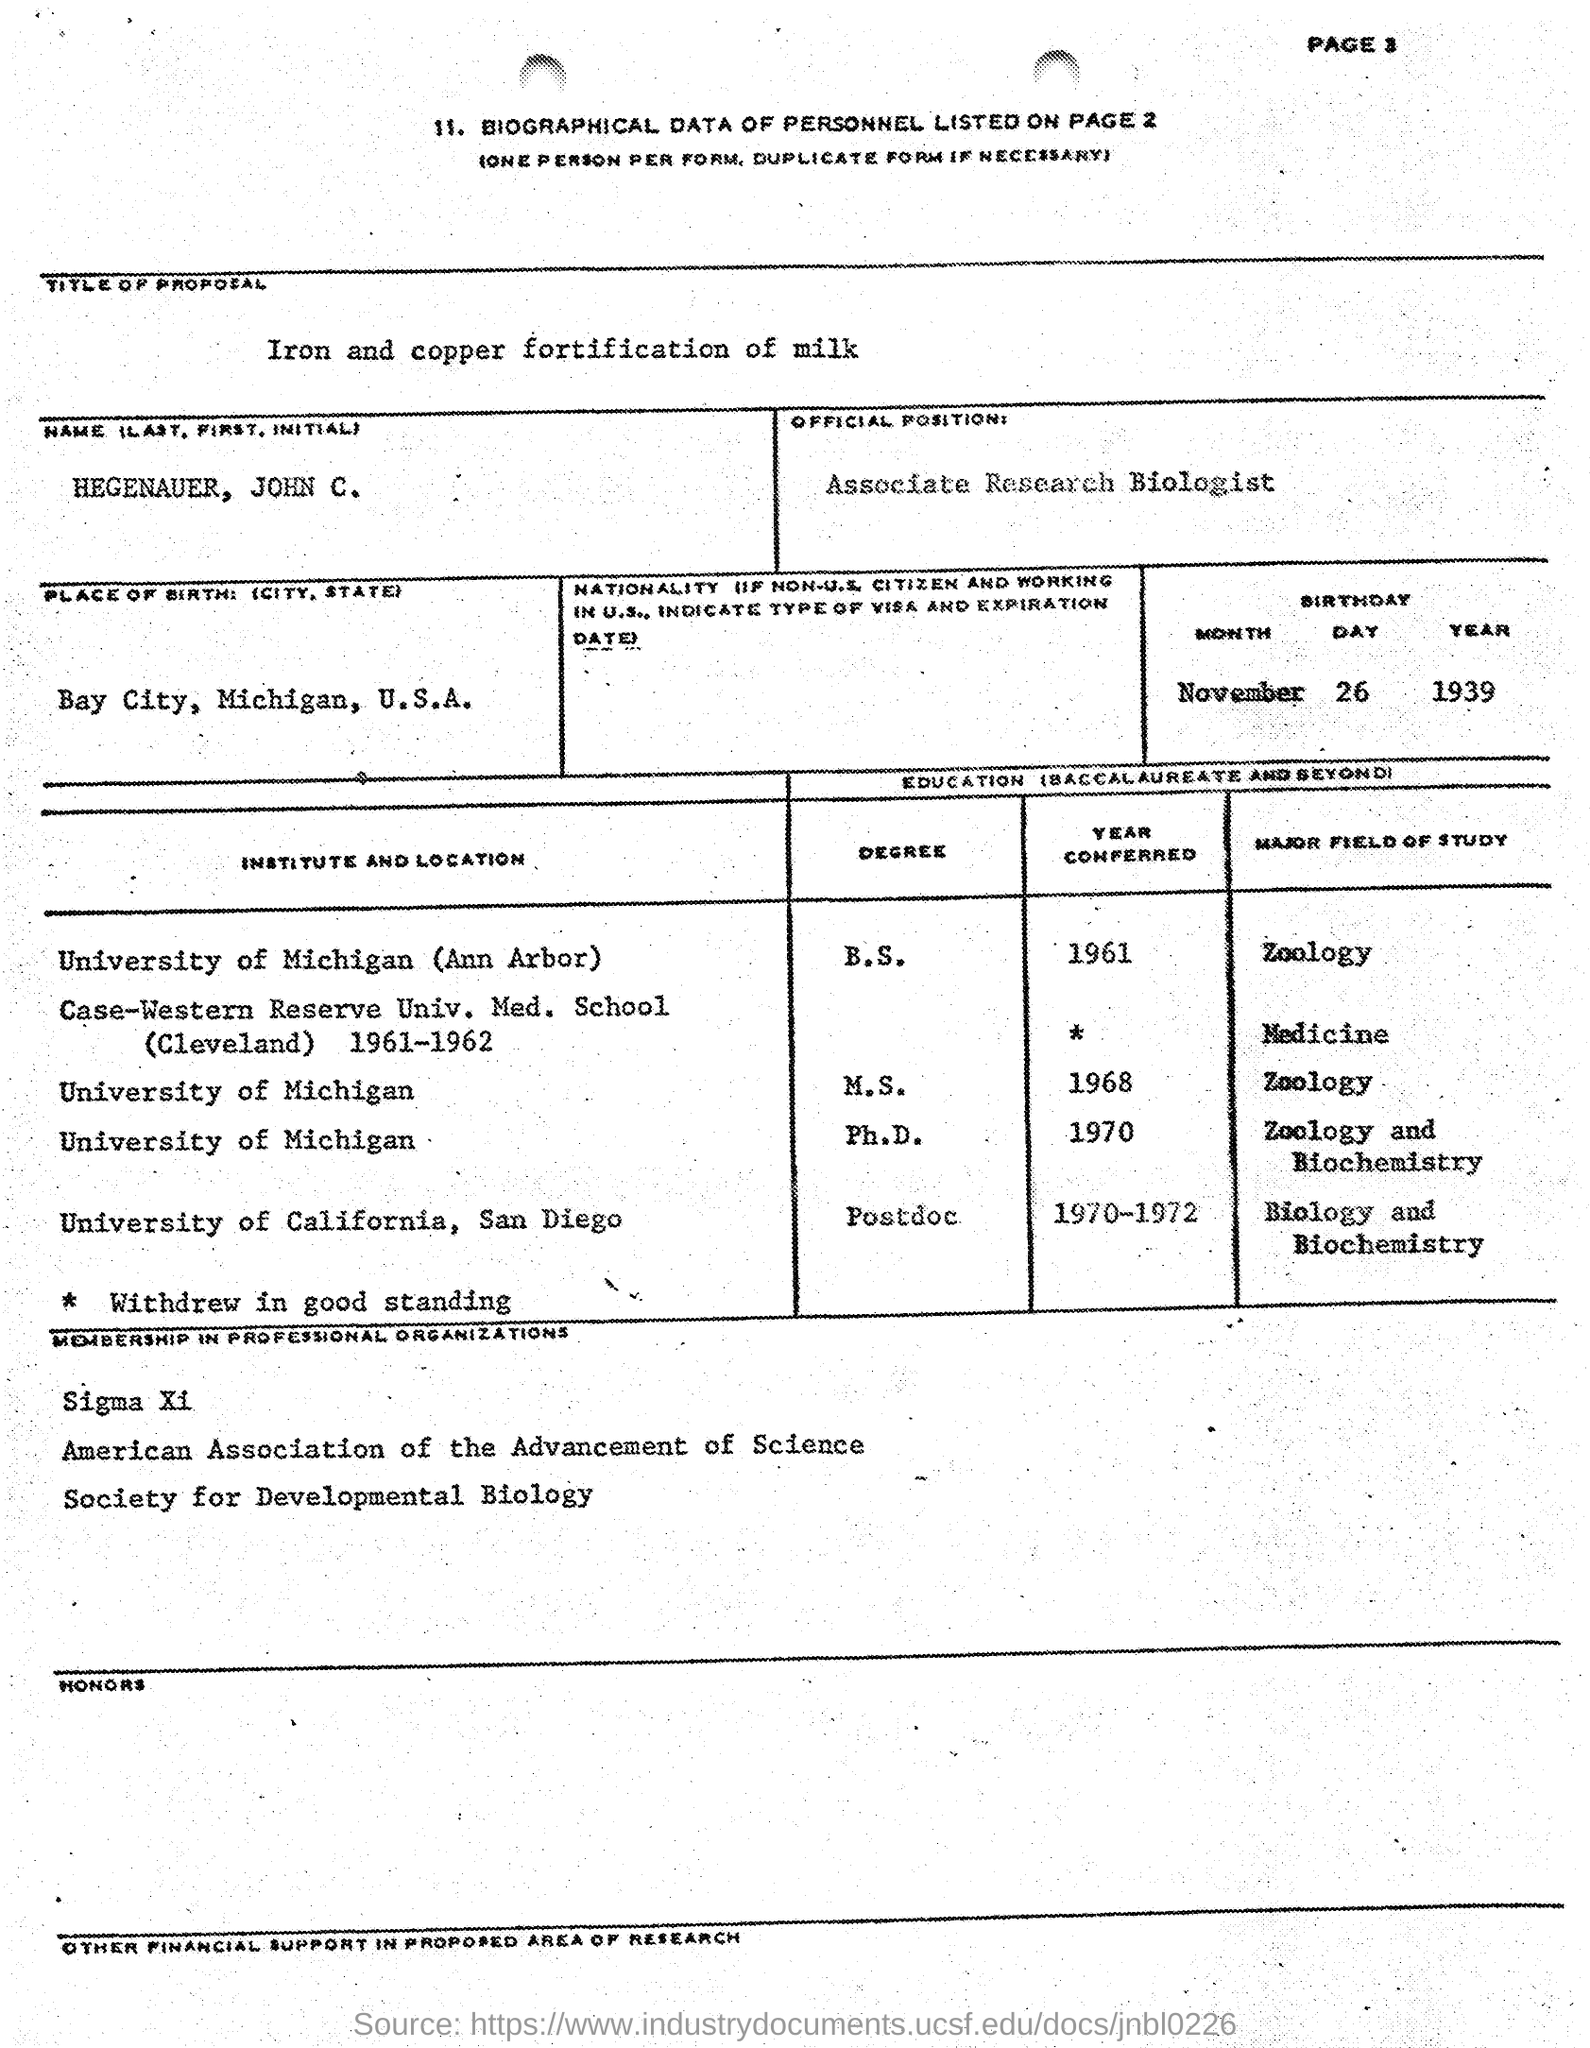Where is the biographical data of the personnel is listed on ?
Your answer should be very brief. PAGE 2. What is the title of proposal ?
Your answer should be very brief. IRON AND COPPER FORTIFICATION OF MILK. What is the offical position ?
Offer a terse response. ASSOCIATE RESEARCH BIOLOGIST. What is the place of birth ?
Offer a very short reply. Bay City, Michigan, U.S.A. What is the date of birth ?
Your answer should be very brief. NOVEMBER 26 1939. 